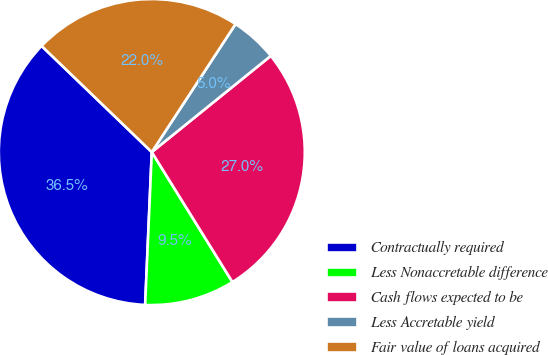Convert chart to OTSL. <chart><loc_0><loc_0><loc_500><loc_500><pie_chart><fcel>Contractually required<fcel>Less Nonaccretable difference<fcel>Cash flows expected to be<fcel>Less Accretable yield<fcel>Fair value of loans acquired<nl><fcel>36.51%<fcel>9.53%<fcel>26.98%<fcel>4.96%<fcel>22.02%<nl></chart> 